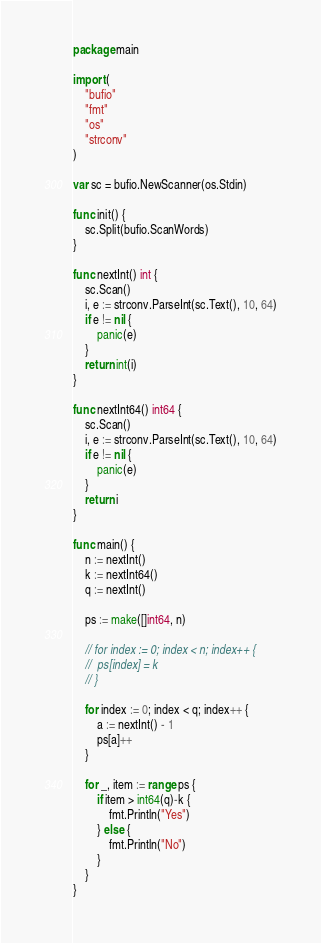<code> <loc_0><loc_0><loc_500><loc_500><_Go_>package main

import (
	"bufio"
	"fmt"
	"os"
	"strconv"
)

var sc = bufio.NewScanner(os.Stdin)

func init() {
	sc.Split(bufio.ScanWords)
}

func nextInt() int {
	sc.Scan()
	i, e := strconv.ParseInt(sc.Text(), 10, 64)
	if e != nil {
		panic(e)
	}
	return int(i)
}

func nextInt64() int64 {
	sc.Scan()
	i, e := strconv.ParseInt(sc.Text(), 10, 64)
	if e != nil {
		panic(e)
	}
	return i
}

func main() {
	n := nextInt()
	k := nextInt64()
	q := nextInt()

	ps := make([]int64, n)

	// for index := 0; index < n; index++ {
	// 	ps[index] = k
	// }

	for index := 0; index < q; index++ {
		a := nextInt() - 1
		ps[a]++
	}

	for _, item := range ps {
		if item > int64(q)-k {
			fmt.Println("Yes")
		} else {
			fmt.Println("No")
		}
	}
}
</code> 